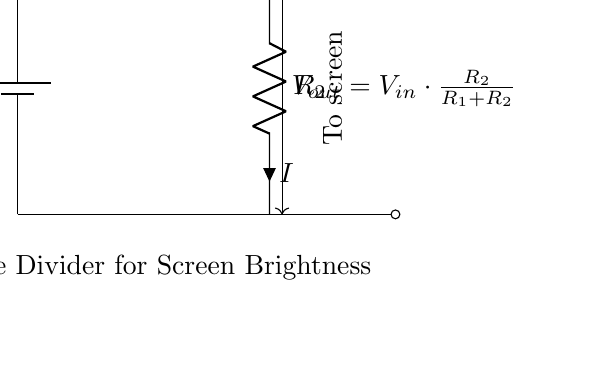What is the purpose of this circuit? The circuit is designed to adjust the brightness of a screen by using a voltage divider. The output voltage is determined by the ratio of the resistors, allowing for control over the brightness level.
Answer: Adjust screen brightness What does V_out represent? V_out represents the output voltage across resistor R_2, which is delivered to the screen. It influences how bright the screen will be based on the input voltage and the resistor values.
Answer: Output voltage What two components are used in the voltage divider? The two components used in the voltage divider are resistors R_1 and R_2. These resistors split the voltage and create the desired output for the screen brightness adjustment.
Answer: R1 and R2 What happens to V_out if R_2 is increased? If R_2 is increased, V_out rises, as it increases the proportion of the total voltage that is dropped across R_2. This leads to a brighter screen if input voltage remains constant.
Answer: V_out rises What is the voltage equation shown in the diagram? The voltage equation shown in the diagram is V_out = V_in * (R_2 / (R_1 + R_2)). This defines how the output is calculated based on the input voltage and resistor values, indicative of the voltage divider principle.
Answer: V_out = V_in * (R_2 / (R_1 + R_2)) What is the role of the battery in this circuit? The battery provides the input voltage (V_in) necessary for the circuit to function. It supplies the electrical energy that allows the voltage divider to operate and adjust brightness for the screen.
Answer: Supply voltage What does the current direction indicate? The current direction indicates the flow of electric charge from the battery through R_1 and R_2 before reaching the screen. It shows how the circuit is completing a path for electricity to flow, allowing for brightness control.
Answer: Current flow direction 